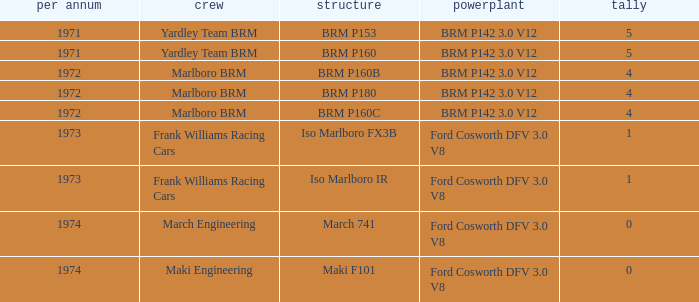What are the highest points for the team of marlboro brm with brm p180 as the chassis? 4.0. 